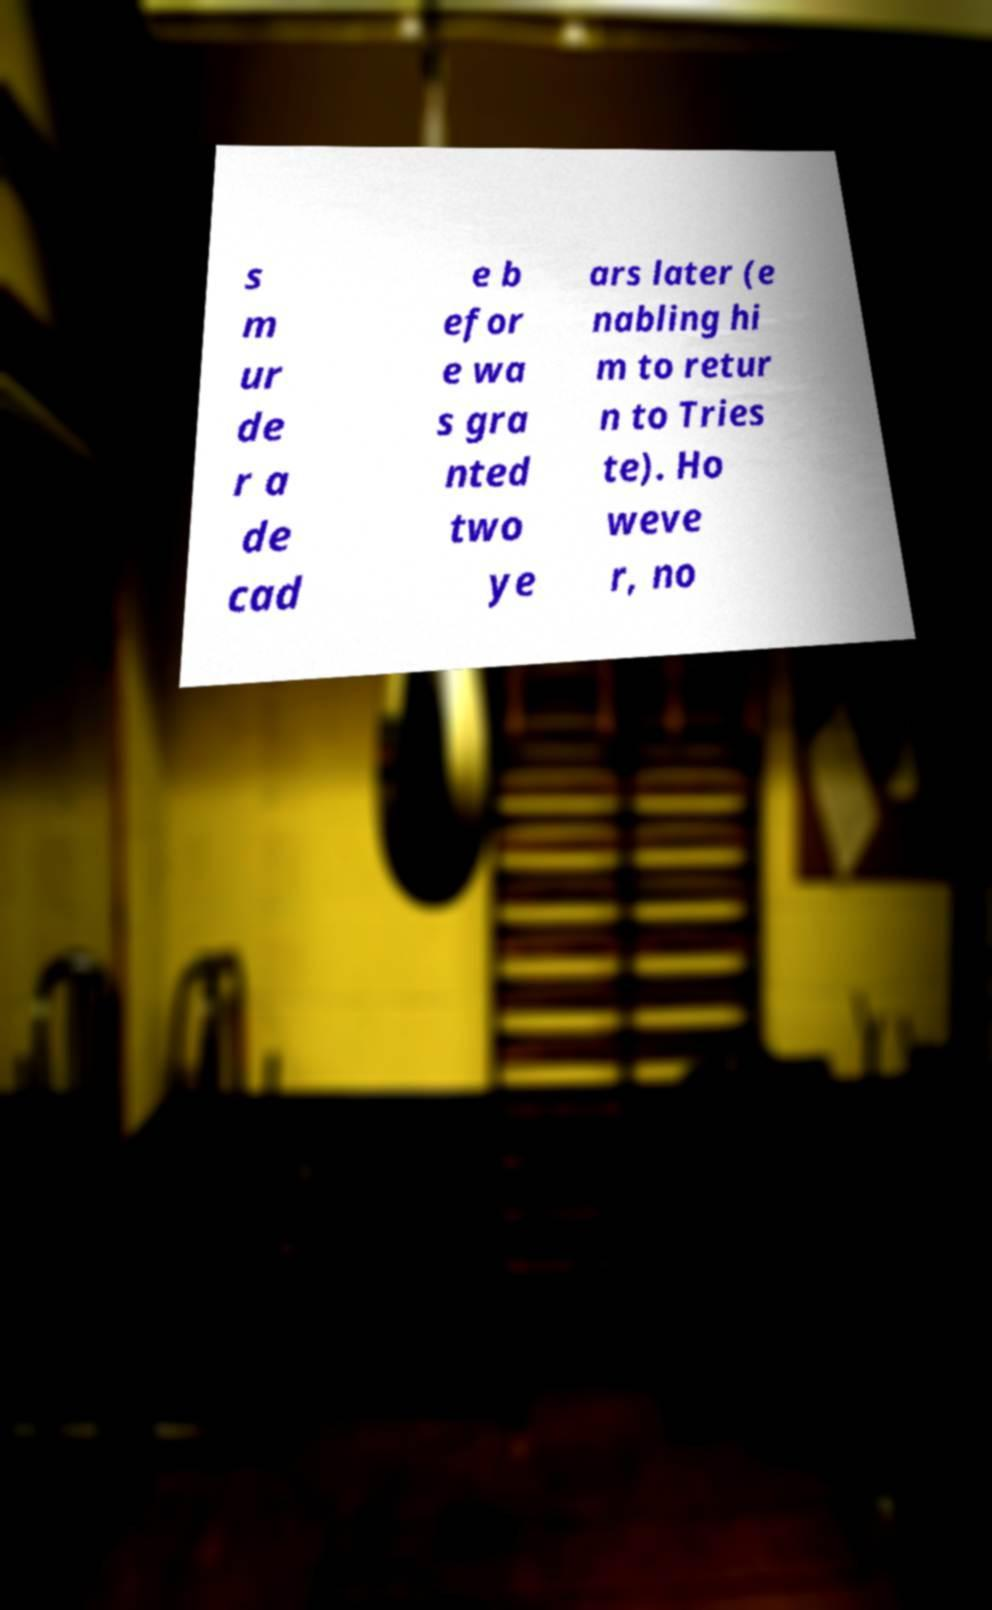Please identify and transcribe the text found in this image. s m ur de r a de cad e b efor e wa s gra nted two ye ars later (e nabling hi m to retur n to Tries te). Ho weve r, no 